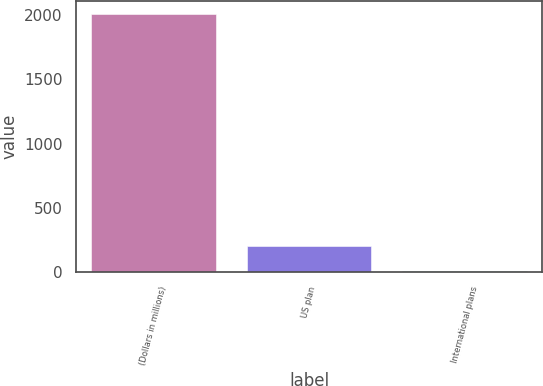Convert chart. <chart><loc_0><loc_0><loc_500><loc_500><bar_chart><fcel>(Dollars in millions)<fcel>US plan<fcel>International plans<nl><fcel>2007<fcel>206.1<fcel>6<nl></chart> 